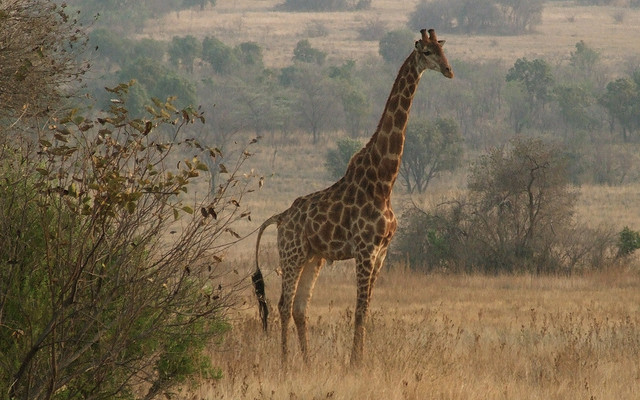<image>Is the tree limb in the foreground an acacia? I am not sure if the tree limb in the foreground is an acacia. It can be both yes and no. Is the tree limb in the foreground an acacia? I don't know if the tree limb in the foreground is an acacia. It is unclear. 